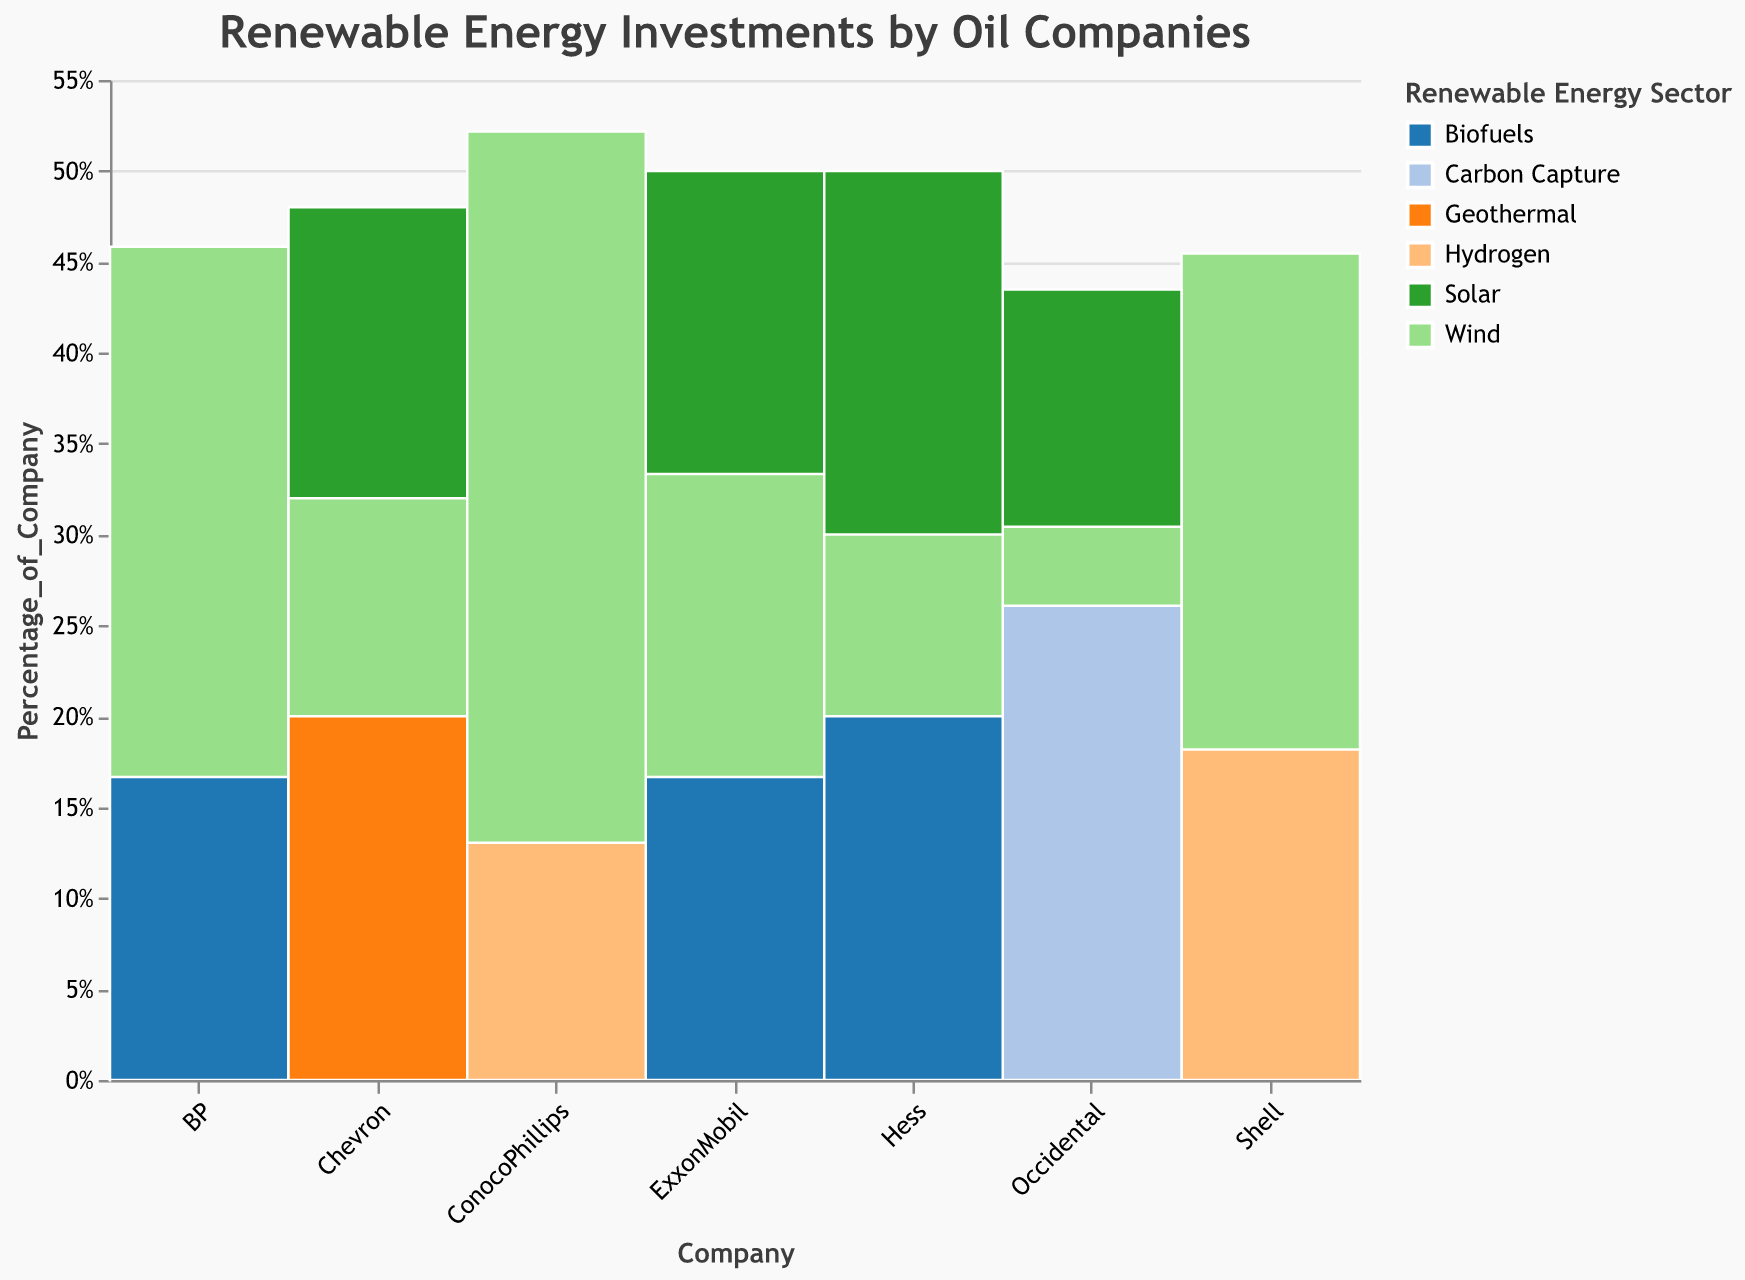What's the title of the chart? The title is usually located at the top of the figure and reads "Renewable Energy Investments by Oil Companies".
Answer: Renewable Energy Investments by Oil Companies Which company has the highest percentage of investments in the Wind sector? Look at the height of the Wind segment for each company and compare. Shell has the highest portion dedicated to Wind investments.
Answer: Shell What is the investment percentage in Biofuels by ExxonMobil? Find the segment for ExxonMobil and identify the Biofuels section. The tooltip can also provide exact values.
Answer: 5% How many renewable energy sectors has Chevron invested in? Count the distinct segments corresponding to Chevron. Chevron has investments in Solar, Wind, and Geothermal (3 sectors).
Answer: 3 Between Shell and BP, which company has a higher percentage of its total renewable investments in the Solar sector? Compare the heights of the Solar segments for Shell and BP relative to their total heights. Shell’s Solar investment proportion looks higher than BP’s.
Answer: Shell What is the sum of the investment percentages in the Wind sector for all companies? Sum the percentages for all the segments labeled Wind across all companies (10+25+22+8+12+7+3).
Answer: 87% Are there any companies that invest in Hydrogen? If so, which company or companies? Look for segments labeled Hydrogen and indentify the companies associated. Shell and ConocoPhillips invest in Hydrogen.
Answer: Shell, ConocoPhillips Calculate the total renewable energy investment percentage by Shell. Add up the investment percentages for Shell in each sector it invests in (20+25+10).
Answer: 55% Which renewable sector appears most diversified across different companies? Identify the sector appearing in the most companies’ segments. Sectors like Solar and Wind appear in many companies (6 for Solar, 6 for Wind).
Answer: Solar, Wind Do any small size companies invest in Carbon Capture? Check the segments for small sized companies and look for Carbon Capture. No small companies invest in Carbon Capture; only Occidental (medium size) does.
Answer: No 